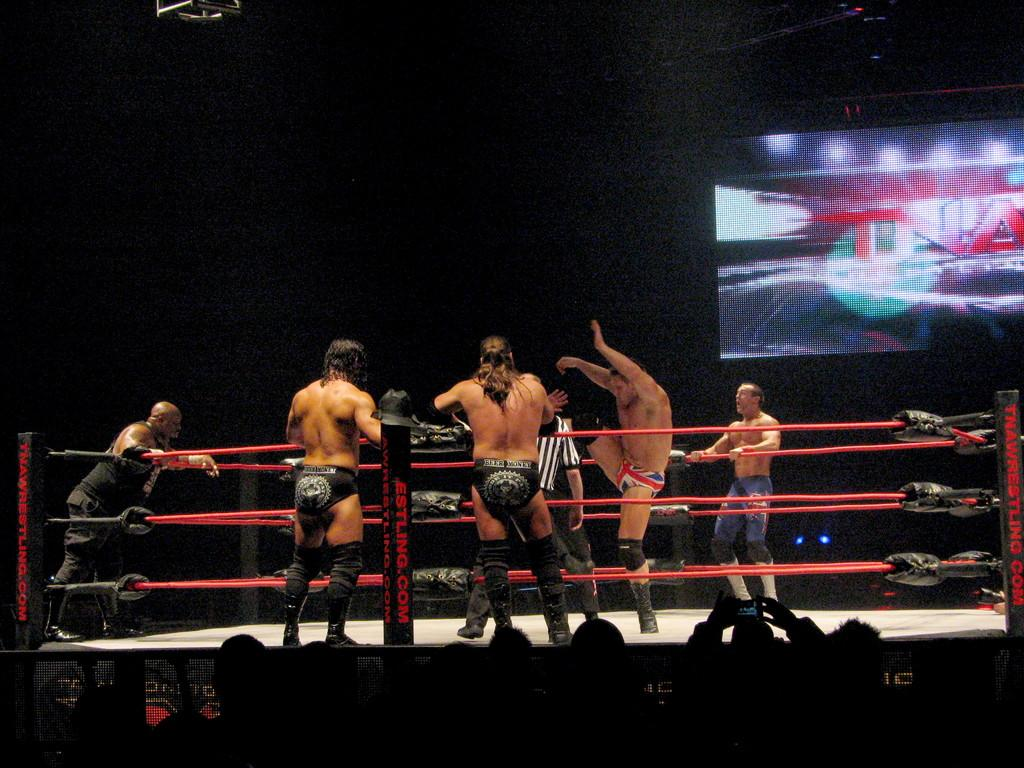<image>
Create a compact narrative representing the image presented. Wresters in the ring with men in black speedos watching from outside the ring, there is a large screen with TNA on it. 